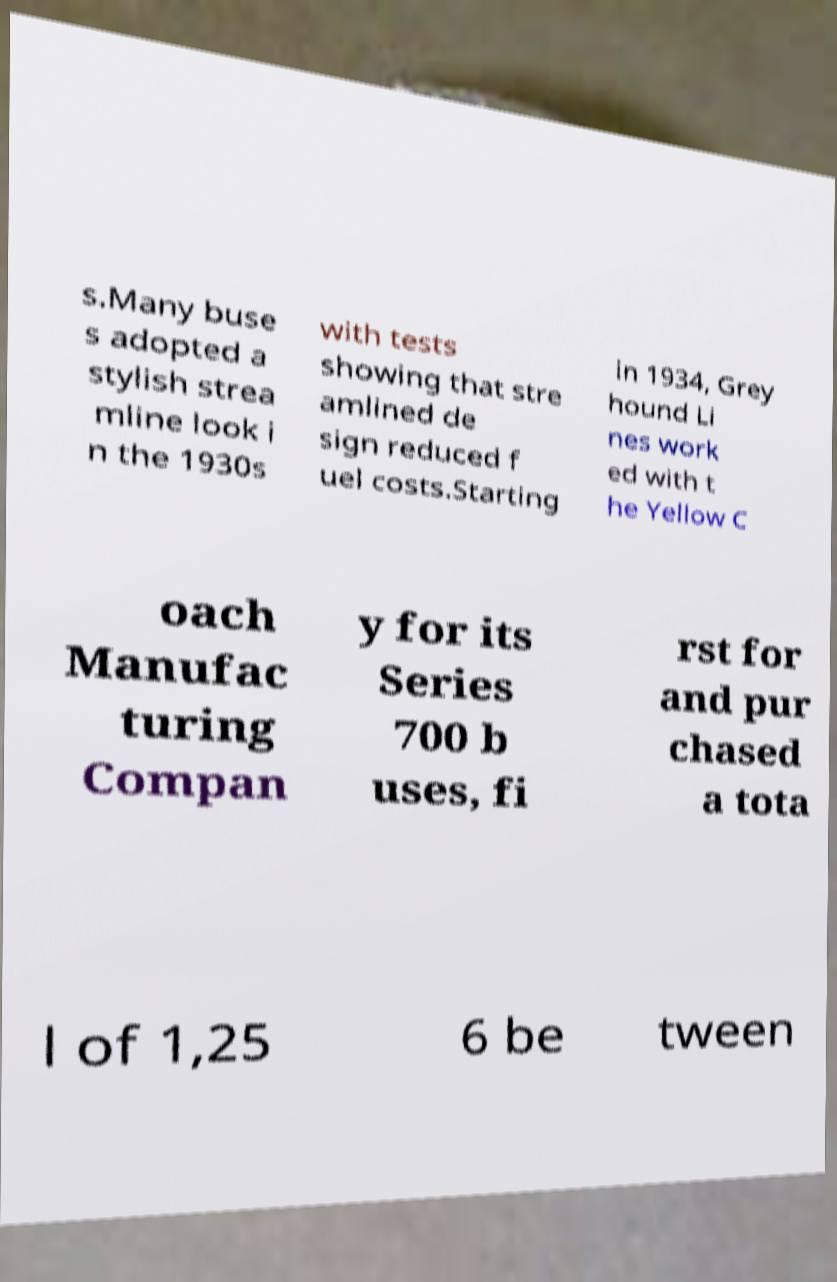For documentation purposes, I need the text within this image transcribed. Could you provide that? s.Many buse s adopted a stylish strea mline look i n the 1930s with tests showing that stre amlined de sign reduced f uel costs.Starting in 1934, Grey hound Li nes work ed with t he Yellow C oach Manufac turing Compan y for its Series 700 b uses, fi rst for and pur chased a tota l of 1,25 6 be tween 